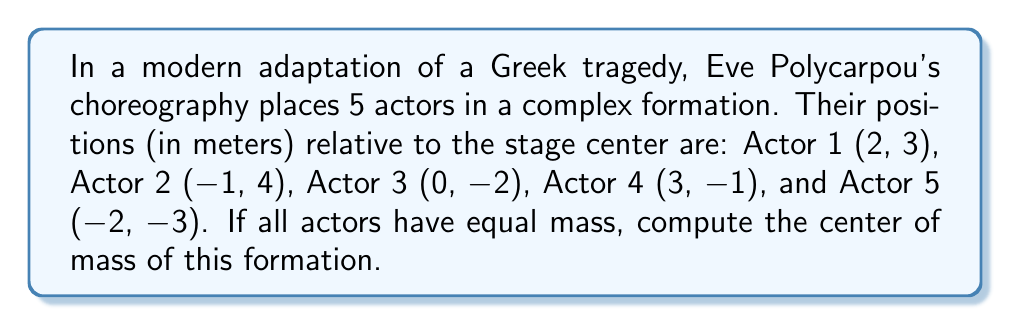Solve this math problem. To find the center of mass for a system of equal-mass particles, we need to calculate the average position of all particles. Let's approach this step-by-step:

1) First, let's recall the formula for the center of mass $(x_{cm}, y_{cm})$ for $n$ particles of equal mass:

   $$ x_{cm} = \frac{1}{n} \sum_{i=1}^n x_i $$
   $$ y_{cm} = \frac{1}{n} \sum_{i=1}^n y_i $$

2) We have 5 actors (n = 5), so let's sum their x-coordinates:

   $$ \sum x_i = 2 + (-1) + 0 + 3 + (-2) = 2 $$

3) Now, let's sum their y-coordinates:

   $$ \sum y_i = 3 + 4 + (-2) + (-1) + (-3) = 1 $$

4) Apply the formulas:

   $$ x_{cm} = \frac{1}{5} \cdot 2 = 0.4 $$
   $$ y_{cm} = \frac{1}{5} \cdot 1 = 0.2 $$

5) Therefore, the center of mass is at the point (0.4, 0.2) meters relative to the stage center.
Answer: (0.4, 0.2) meters 